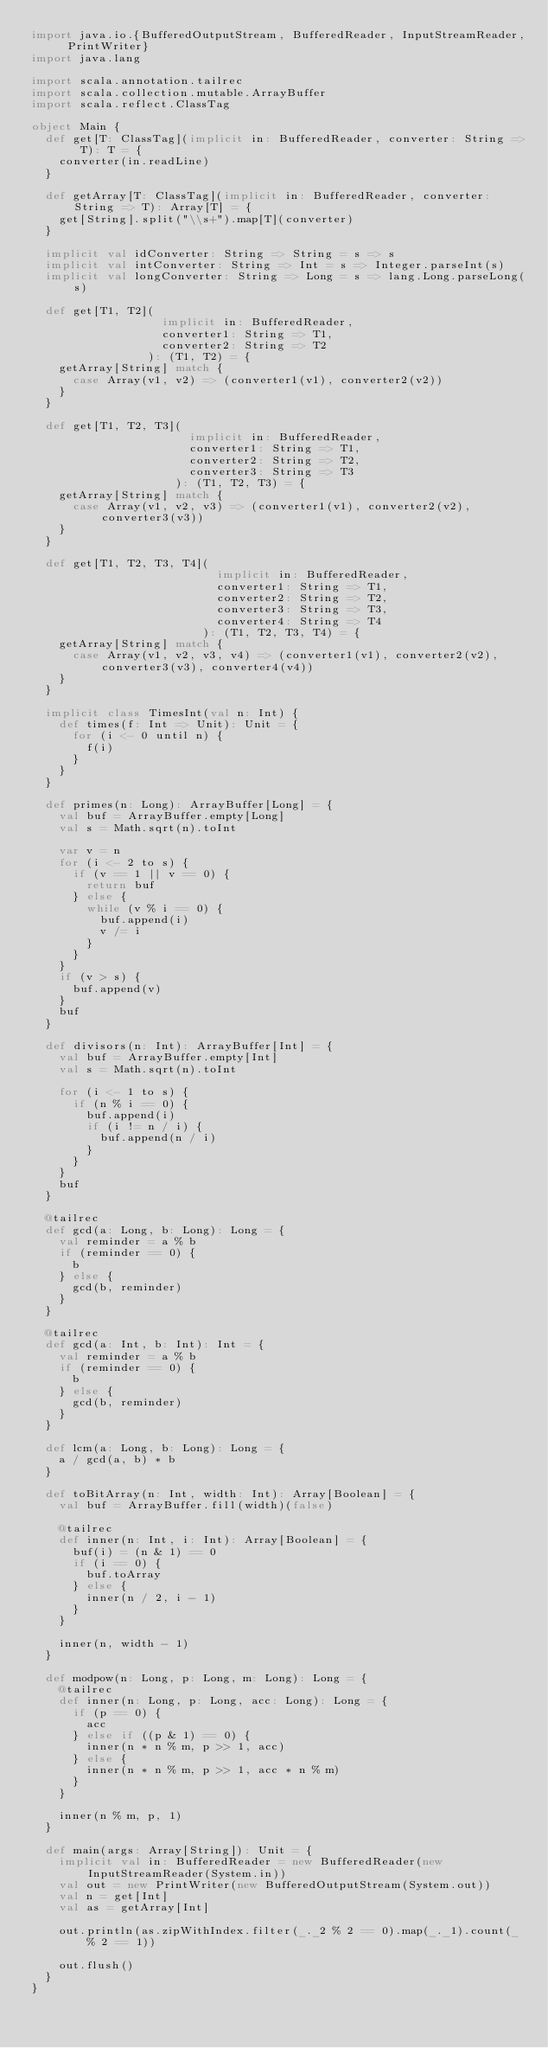<code> <loc_0><loc_0><loc_500><loc_500><_Scala_>import java.io.{BufferedOutputStream, BufferedReader, InputStreamReader, PrintWriter}
import java.lang

import scala.annotation.tailrec
import scala.collection.mutable.ArrayBuffer
import scala.reflect.ClassTag

object Main {
  def get[T: ClassTag](implicit in: BufferedReader, converter: String => T): T = {
    converter(in.readLine)
  }

  def getArray[T: ClassTag](implicit in: BufferedReader, converter: String => T): Array[T] = {
    get[String].split("\\s+").map[T](converter)
  }

  implicit val idConverter: String => String = s => s
  implicit val intConverter: String => Int = s => Integer.parseInt(s)
  implicit val longConverter: String => Long = s => lang.Long.parseLong(s)

  def get[T1, T2](
                   implicit in: BufferedReader,
                   converter1: String => T1,
                   converter2: String => T2
                 ): (T1, T2) = {
    getArray[String] match {
      case Array(v1, v2) => (converter1(v1), converter2(v2))
    }
  }

  def get[T1, T2, T3](
                       implicit in: BufferedReader,
                       converter1: String => T1,
                       converter2: String => T2,
                       converter3: String => T3
                     ): (T1, T2, T3) = {
    getArray[String] match {
      case Array(v1, v2, v3) => (converter1(v1), converter2(v2), converter3(v3))
    }
  }

  def get[T1, T2, T3, T4](
                           implicit in: BufferedReader,
                           converter1: String => T1,
                           converter2: String => T2,
                           converter3: String => T3,
                           converter4: String => T4
                         ): (T1, T2, T3, T4) = {
    getArray[String] match {
      case Array(v1, v2, v3, v4) => (converter1(v1), converter2(v2), converter3(v3), converter4(v4))
    }
  }

  implicit class TimesInt(val n: Int) {
    def times(f: Int => Unit): Unit = {
      for (i <- 0 until n) {
        f(i)
      }
    }
  }

  def primes(n: Long): ArrayBuffer[Long] = {
    val buf = ArrayBuffer.empty[Long]
    val s = Math.sqrt(n).toInt

    var v = n
    for (i <- 2 to s) {
      if (v == 1 || v == 0) {
        return buf
      } else {
        while (v % i == 0) {
          buf.append(i)
          v /= i
        }
      }
    }
    if (v > s) {
      buf.append(v)
    }
    buf
  }

  def divisors(n: Int): ArrayBuffer[Int] = {
    val buf = ArrayBuffer.empty[Int]
    val s = Math.sqrt(n).toInt

    for (i <- 1 to s) {
      if (n % i == 0) {
        buf.append(i)
        if (i != n / i) {
          buf.append(n / i)
        }
      }
    }
    buf
  }

  @tailrec
  def gcd(a: Long, b: Long): Long = {
    val reminder = a % b
    if (reminder == 0) {
      b
    } else {
      gcd(b, reminder)
    }
  }

  @tailrec
  def gcd(a: Int, b: Int): Int = {
    val reminder = a % b
    if (reminder == 0) {
      b
    } else {
      gcd(b, reminder)
    }
  }

  def lcm(a: Long, b: Long): Long = {
    a / gcd(a, b) * b
  }

  def toBitArray(n: Int, width: Int): Array[Boolean] = {
    val buf = ArrayBuffer.fill(width)(false)

    @tailrec
    def inner(n: Int, i: Int): Array[Boolean] = {
      buf(i) = (n & 1) == 0
      if (i == 0) {
        buf.toArray
      } else {
        inner(n / 2, i - 1)
      }
    }

    inner(n, width - 1)
  }

  def modpow(n: Long, p: Long, m: Long): Long = {
    @tailrec
    def inner(n: Long, p: Long, acc: Long): Long = {
      if (p == 0) {
        acc
      } else if ((p & 1) == 0) {
        inner(n * n % m, p >> 1, acc)
      } else {
        inner(n * n % m, p >> 1, acc * n % m)
      }
    }

    inner(n % m, p, 1)
  }

  def main(args: Array[String]): Unit = {
    implicit val in: BufferedReader = new BufferedReader(new InputStreamReader(System.in))
    val out = new PrintWriter(new BufferedOutputStream(System.out))
    val n = get[Int]
    val as = getArray[Int]

    out.println(as.zipWithIndex.filter(_._2 % 2 == 0).map(_._1).count(_ % 2 == 1))

    out.flush()
  }
}</code> 